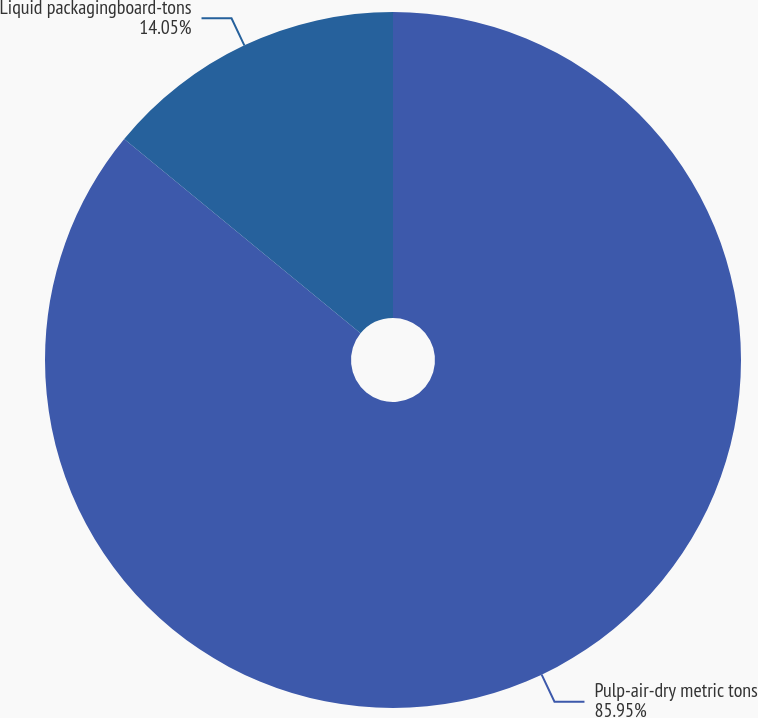Convert chart. <chart><loc_0><loc_0><loc_500><loc_500><pie_chart><fcel>Pulp-air-dry metric tons<fcel>Liquid packagingboard-tons<nl><fcel>85.95%<fcel>14.05%<nl></chart> 